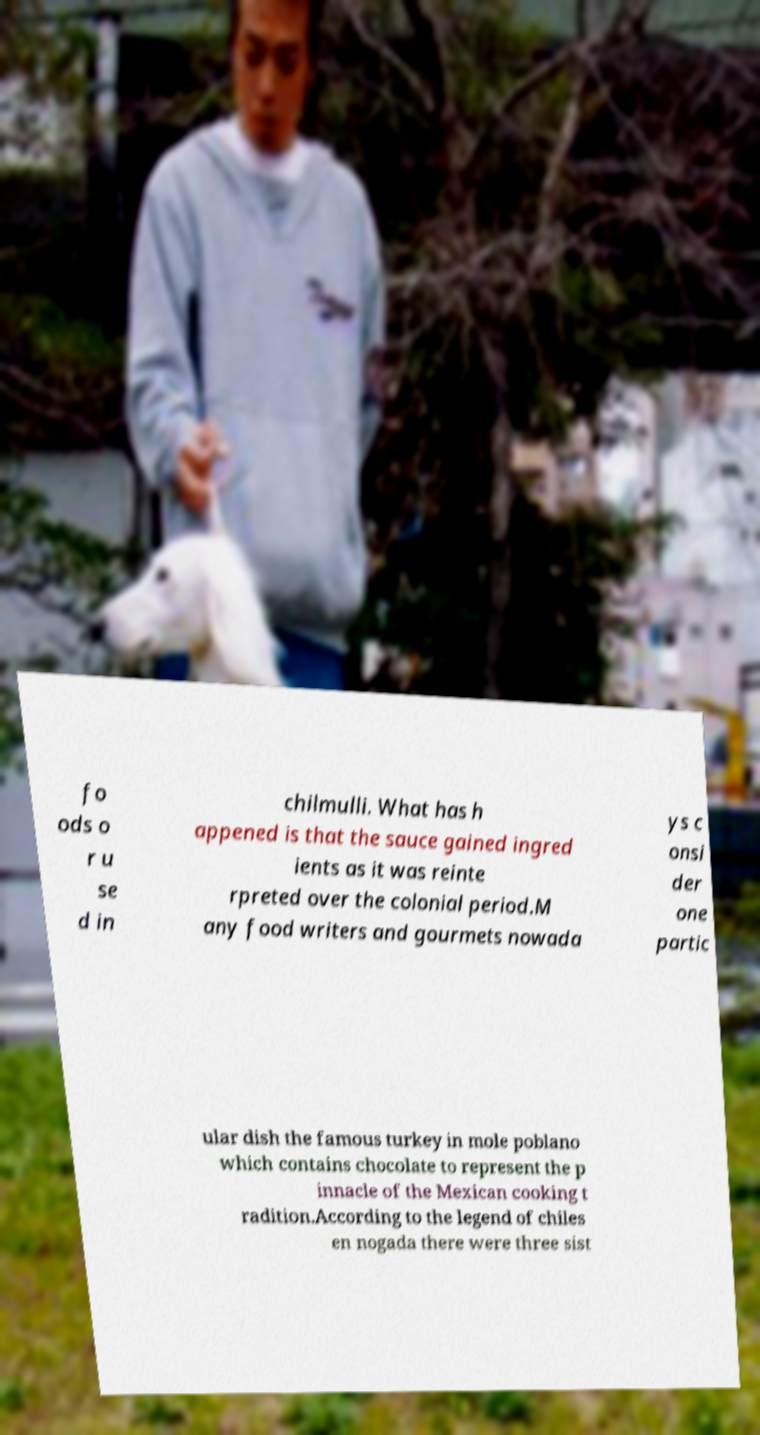I need the written content from this picture converted into text. Can you do that? fo ods o r u se d in chilmulli. What has h appened is that the sauce gained ingred ients as it was reinte rpreted over the colonial period.M any food writers and gourmets nowada ys c onsi der one partic ular dish the famous turkey in mole poblano which contains chocolate to represent the p innacle of the Mexican cooking t radition.According to the legend of chiles en nogada there were three sist 